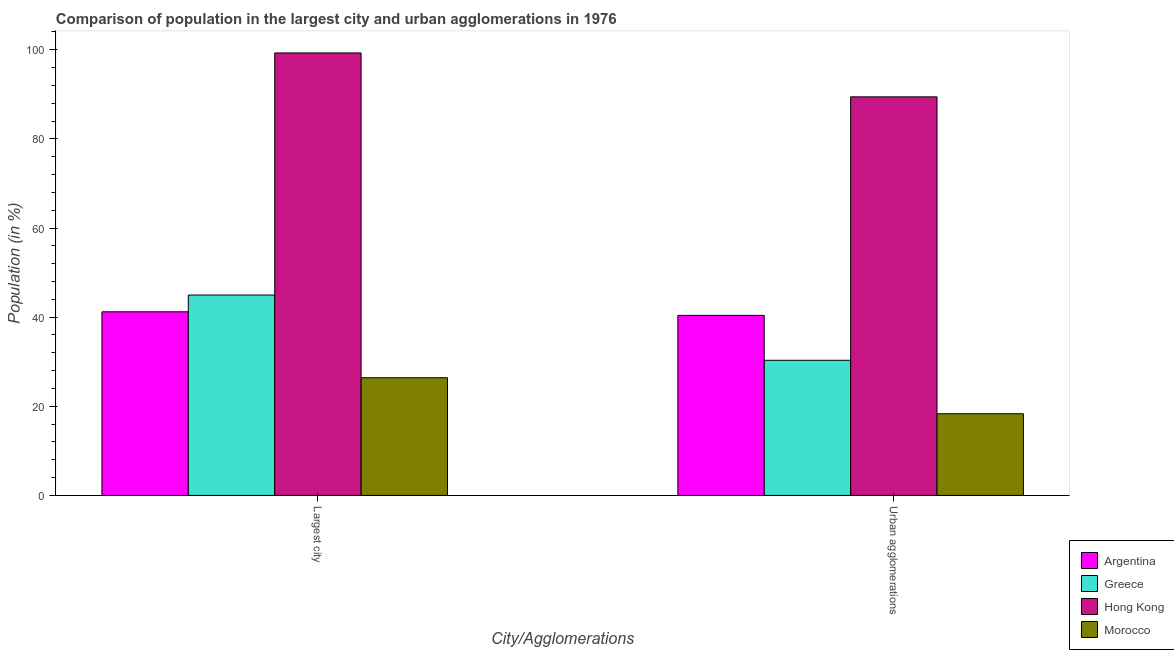How many different coloured bars are there?
Make the answer very short. 4. Are the number of bars per tick equal to the number of legend labels?
Offer a very short reply. Yes. What is the label of the 2nd group of bars from the left?
Your response must be concise. Urban agglomerations. What is the population in urban agglomerations in Greece?
Your answer should be very brief. 30.32. Across all countries, what is the maximum population in the largest city?
Ensure brevity in your answer.  99.29. Across all countries, what is the minimum population in the largest city?
Provide a short and direct response. 26.4. In which country was the population in the largest city maximum?
Offer a very short reply. Hong Kong. In which country was the population in the largest city minimum?
Your answer should be very brief. Morocco. What is the total population in urban agglomerations in the graph?
Ensure brevity in your answer.  178.49. What is the difference between the population in the largest city in Hong Kong and that in Greece?
Your answer should be compact. 54.32. What is the difference between the population in urban agglomerations in Morocco and the population in the largest city in Greece?
Your answer should be very brief. -26.64. What is the average population in urban agglomerations per country?
Ensure brevity in your answer.  44.62. What is the difference between the population in the largest city and population in urban agglomerations in Greece?
Give a very brief answer. 14.65. In how many countries, is the population in urban agglomerations greater than 44 %?
Provide a short and direct response. 1. What is the ratio of the population in the largest city in Morocco to that in Greece?
Make the answer very short. 0.59. Is the population in the largest city in Argentina less than that in Morocco?
Your answer should be compact. No. In how many countries, is the population in urban agglomerations greater than the average population in urban agglomerations taken over all countries?
Provide a short and direct response. 1. What does the 1st bar from the left in Largest city represents?
Provide a short and direct response. Argentina. What does the 3rd bar from the right in Urban agglomerations represents?
Provide a succinct answer. Greece. Are all the bars in the graph horizontal?
Provide a short and direct response. No. How many countries are there in the graph?
Offer a very short reply. 4. Are the values on the major ticks of Y-axis written in scientific E-notation?
Your response must be concise. No. Does the graph contain any zero values?
Your answer should be very brief. No. Does the graph contain grids?
Offer a terse response. No. How are the legend labels stacked?
Your answer should be compact. Vertical. What is the title of the graph?
Your answer should be very brief. Comparison of population in the largest city and urban agglomerations in 1976. What is the label or title of the X-axis?
Your response must be concise. City/Agglomerations. What is the Population (in %) of Argentina in Largest city?
Offer a terse response. 41.2. What is the Population (in %) of Greece in Largest city?
Provide a succinct answer. 44.97. What is the Population (in %) in Hong Kong in Largest city?
Offer a terse response. 99.29. What is the Population (in %) in Morocco in Largest city?
Offer a very short reply. 26.4. What is the Population (in %) of Argentina in Urban agglomerations?
Your response must be concise. 40.4. What is the Population (in %) of Greece in Urban agglomerations?
Your answer should be compact. 30.32. What is the Population (in %) in Hong Kong in Urban agglomerations?
Keep it short and to the point. 89.44. What is the Population (in %) of Morocco in Urban agglomerations?
Offer a very short reply. 18.33. Across all City/Agglomerations, what is the maximum Population (in %) in Argentina?
Your answer should be compact. 41.2. Across all City/Agglomerations, what is the maximum Population (in %) in Greece?
Offer a very short reply. 44.97. Across all City/Agglomerations, what is the maximum Population (in %) in Hong Kong?
Keep it short and to the point. 99.29. Across all City/Agglomerations, what is the maximum Population (in %) of Morocco?
Keep it short and to the point. 26.4. Across all City/Agglomerations, what is the minimum Population (in %) in Argentina?
Provide a succinct answer. 40.4. Across all City/Agglomerations, what is the minimum Population (in %) in Greece?
Provide a succinct answer. 30.32. Across all City/Agglomerations, what is the minimum Population (in %) in Hong Kong?
Ensure brevity in your answer.  89.44. Across all City/Agglomerations, what is the minimum Population (in %) in Morocco?
Keep it short and to the point. 18.33. What is the total Population (in %) of Argentina in the graph?
Ensure brevity in your answer.  81.61. What is the total Population (in %) in Greece in the graph?
Make the answer very short. 75.3. What is the total Population (in %) in Hong Kong in the graph?
Offer a terse response. 188.72. What is the total Population (in %) of Morocco in the graph?
Offer a very short reply. 44.73. What is the difference between the Population (in %) of Argentina in Largest city and that in Urban agglomerations?
Offer a terse response. 0.8. What is the difference between the Population (in %) of Greece in Largest city and that in Urban agglomerations?
Give a very brief answer. 14.65. What is the difference between the Population (in %) in Hong Kong in Largest city and that in Urban agglomerations?
Offer a terse response. 9.85. What is the difference between the Population (in %) of Morocco in Largest city and that in Urban agglomerations?
Your response must be concise. 8.08. What is the difference between the Population (in %) in Argentina in Largest city and the Population (in %) in Greece in Urban agglomerations?
Your answer should be very brief. 10.88. What is the difference between the Population (in %) in Argentina in Largest city and the Population (in %) in Hong Kong in Urban agglomerations?
Your answer should be compact. -48.23. What is the difference between the Population (in %) in Argentina in Largest city and the Population (in %) in Morocco in Urban agglomerations?
Your response must be concise. 22.87. What is the difference between the Population (in %) in Greece in Largest city and the Population (in %) in Hong Kong in Urban agglomerations?
Your response must be concise. -44.46. What is the difference between the Population (in %) of Greece in Largest city and the Population (in %) of Morocco in Urban agglomerations?
Your response must be concise. 26.64. What is the difference between the Population (in %) of Hong Kong in Largest city and the Population (in %) of Morocco in Urban agglomerations?
Ensure brevity in your answer.  80.96. What is the average Population (in %) in Argentina per City/Agglomerations?
Make the answer very short. 40.8. What is the average Population (in %) in Greece per City/Agglomerations?
Your answer should be very brief. 37.65. What is the average Population (in %) of Hong Kong per City/Agglomerations?
Your answer should be compact. 94.36. What is the average Population (in %) of Morocco per City/Agglomerations?
Your answer should be compact. 22.37. What is the difference between the Population (in %) of Argentina and Population (in %) of Greece in Largest city?
Your answer should be very brief. -3.77. What is the difference between the Population (in %) of Argentina and Population (in %) of Hong Kong in Largest city?
Your answer should be compact. -58.09. What is the difference between the Population (in %) of Argentina and Population (in %) of Morocco in Largest city?
Your answer should be very brief. 14.8. What is the difference between the Population (in %) of Greece and Population (in %) of Hong Kong in Largest city?
Keep it short and to the point. -54.32. What is the difference between the Population (in %) of Greece and Population (in %) of Morocco in Largest city?
Offer a very short reply. 18.57. What is the difference between the Population (in %) of Hong Kong and Population (in %) of Morocco in Largest city?
Keep it short and to the point. 72.88. What is the difference between the Population (in %) of Argentina and Population (in %) of Greece in Urban agglomerations?
Ensure brevity in your answer.  10.08. What is the difference between the Population (in %) of Argentina and Population (in %) of Hong Kong in Urban agglomerations?
Give a very brief answer. -49.03. What is the difference between the Population (in %) in Argentina and Population (in %) in Morocco in Urban agglomerations?
Provide a short and direct response. 22.08. What is the difference between the Population (in %) of Greece and Population (in %) of Hong Kong in Urban agglomerations?
Your answer should be compact. -59.11. What is the difference between the Population (in %) in Greece and Population (in %) in Morocco in Urban agglomerations?
Give a very brief answer. 12. What is the difference between the Population (in %) in Hong Kong and Population (in %) in Morocco in Urban agglomerations?
Your answer should be compact. 71.11. What is the ratio of the Population (in %) of Argentina in Largest city to that in Urban agglomerations?
Make the answer very short. 1.02. What is the ratio of the Population (in %) in Greece in Largest city to that in Urban agglomerations?
Your response must be concise. 1.48. What is the ratio of the Population (in %) of Hong Kong in Largest city to that in Urban agglomerations?
Give a very brief answer. 1.11. What is the ratio of the Population (in %) of Morocco in Largest city to that in Urban agglomerations?
Offer a terse response. 1.44. What is the difference between the highest and the second highest Population (in %) of Argentina?
Make the answer very short. 0.8. What is the difference between the highest and the second highest Population (in %) of Greece?
Keep it short and to the point. 14.65. What is the difference between the highest and the second highest Population (in %) in Hong Kong?
Keep it short and to the point. 9.85. What is the difference between the highest and the second highest Population (in %) in Morocco?
Your answer should be very brief. 8.08. What is the difference between the highest and the lowest Population (in %) of Argentina?
Provide a short and direct response. 0.8. What is the difference between the highest and the lowest Population (in %) of Greece?
Keep it short and to the point. 14.65. What is the difference between the highest and the lowest Population (in %) in Hong Kong?
Your answer should be compact. 9.85. What is the difference between the highest and the lowest Population (in %) of Morocco?
Keep it short and to the point. 8.08. 